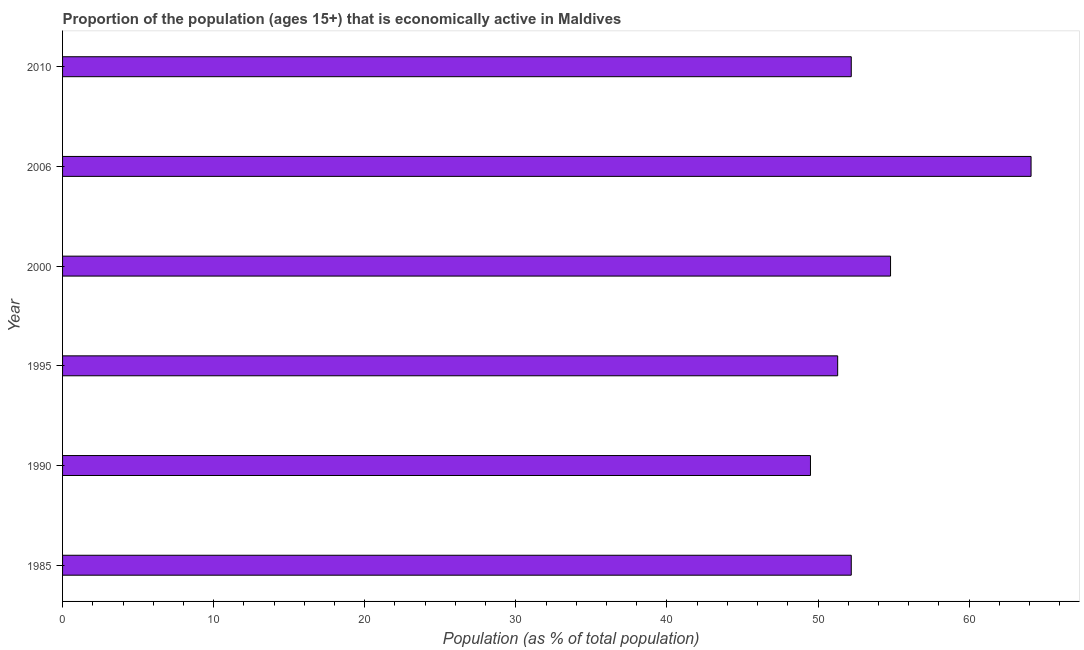Does the graph contain any zero values?
Your response must be concise. No. Does the graph contain grids?
Ensure brevity in your answer.  No. What is the title of the graph?
Your answer should be compact. Proportion of the population (ages 15+) that is economically active in Maldives. What is the label or title of the X-axis?
Your answer should be very brief. Population (as % of total population). What is the percentage of economically active population in 2010?
Your answer should be very brief. 52.2. Across all years, what is the maximum percentage of economically active population?
Your answer should be compact. 64.1. Across all years, what is the minimum percentage of economically active population?
Make the answer very short. 49.5. In which year was the percentage of economically active population minimum?
Your response must be concise. 1990. What is the sum of the percentage of economically active population?
Ensure brevity in your answer.  324.1. What is the difference between the percentage of economically active population in 2000 and 2006?
Your answer should be very brief. -9.3. What is the average percentage of economically active population per year?
Keep it short and to the point. 54.02. What is the median percentage of economically active population?
Your answer should be very brief. 52.2. In how many years, is the percentage of economically active population greater than 48 %?
Keep it short and to the point. 6. Do a majority of the years between 2000 and 1985 (inclusive) have percentage of economically active population greater than 32 %?
Your answer should be compact. Yes. What is the ratio of the percentage of economically active population in 1995 to that in 2000?
Keep it short and to the point. 0.94. Is the percentage of economically active population in 1995 less than that in 2006?
Provide a succinct answer. Yes. What is the difference between the highest and the lowest percentage of economically active population?
Offer a very short reply. 14.6. In how many years, is the percentage of economically active population greater than the average percentage of economically active population taken over all years?
Provide a short and direct response. 2. How many years are there in the graph?
Your response must be concise. 6. What is the Population (as % of total population) of 1985?
Offer a very short reply. 52.2. What is the Population (as % of total population) of 1990?
Ensure brevity in your answer.  49.5. What is the Population (as % of total population) in 1995?
Make the answer very short. 51.3. What is the Population (as % of total population) of 2000?
Your answer should be very brief. 54.8. What is the Population (as % of total population) in 2006?
Keep it short and to the point. 64.1. What is the Population (as % of total population) in 2010?
Ensure brevity in your answer.  52.2. What is the difference between the Population (as % of total population) in 1985 and 1995?
Offer a very short reply. 0.9. What is the difference between the Population (as % of total population) in 1985 and 2000?
Keep it short and to the point. -2.6. What is the difference between the Population (as % of total population) in 1985 and 2010?
Offer a terse response. 0. What is the difference between the Population (as % of total population) in 1990 and 1995?
Your response must be concise. -1.8. What is the difference between the Population (as % of total population) in 1990 and 2006?
Keep it short and to the point. -14.6. What is the difference between the Population (as % of total population) in 1995 and 2010?
Your response must be concise. -0.9. What is the difference between the Population (as % of total population) in 2000 and 2006?
Keep it short and to the point. -9.3. What is the difference between the Population (as % of total population) in 2000 and 2010?
Provide a short and direct response. 2.6. What is the difference between the Population (as % of total population) in 2006 and 2010?
Provide a succinct answer. 11.9. What is the ratio of the Population (as % of total population) in 1985 to that in 1990?
Keep it short and to the point. 1.05. What is the ratio of the Population (as % of total population) in 1985 to that in 2000?
Provide a short and direct response. 0.95. What is the ratio of the Population (as % of total population) in 1985 to that in 2006?
Your response must be concise. 0.81. What is the ratio of the Population (as % of total population) in 1985 to that in 2010?
Provide a succinct answer. 1. What is the ratio of the Population (as % of total population) in 1990 to that in 2000?
Your response must be concise. 0.9. What is the ratio of the Population (as % of total population) in 1990 to that in 2006?
Offer a very short reply. 0.77. What is the ratio of the Population (as % of total population) in 1990 to that in 2010?
Provide a short and direct response. 0.95. What is the ratio of the Population (as % of total population) in 1995 to that in 2000?
Ensure brevity in your answer.  0.94. What is the ratio of the Population (as % of total population) in 1995 to that in 2006?
Make the answer very short. 0.8. What is the ratio of the Population (as % of total population) in 2000 to that in 2006?
Keep it short and to the point. 0.85. What is the ratio of the Population (as % of total population) in 2000 to that in 2010?
Keep it short and to the point. 1.05. What is the ratio of the Population (as % of total population) in 2006 to that in 2010?
Ensure brevity in your answer.  1.23. 